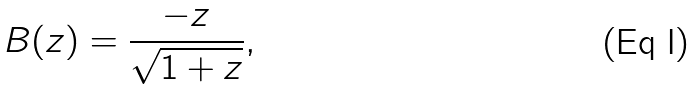Convert formula to latex. <formula><loc_0><loc_0><loc_500><loc_500>B ( z ) = \frac { - z } { \sqrt { 1 + z } } ,</formula> 